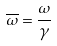Convert formula to latex. <formula><loc_0><loc_0><loc_500><loc_500>\overline { \omega } = \frac { \omega } { \gamma }</formula> 